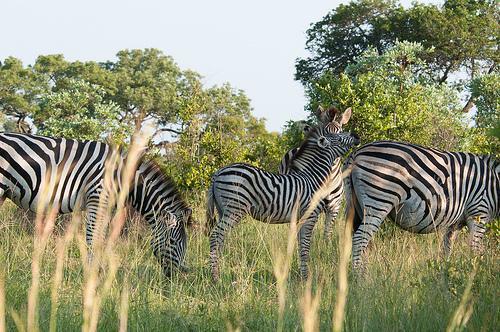How many zebras are there?
Give a very brief answer. 4. 